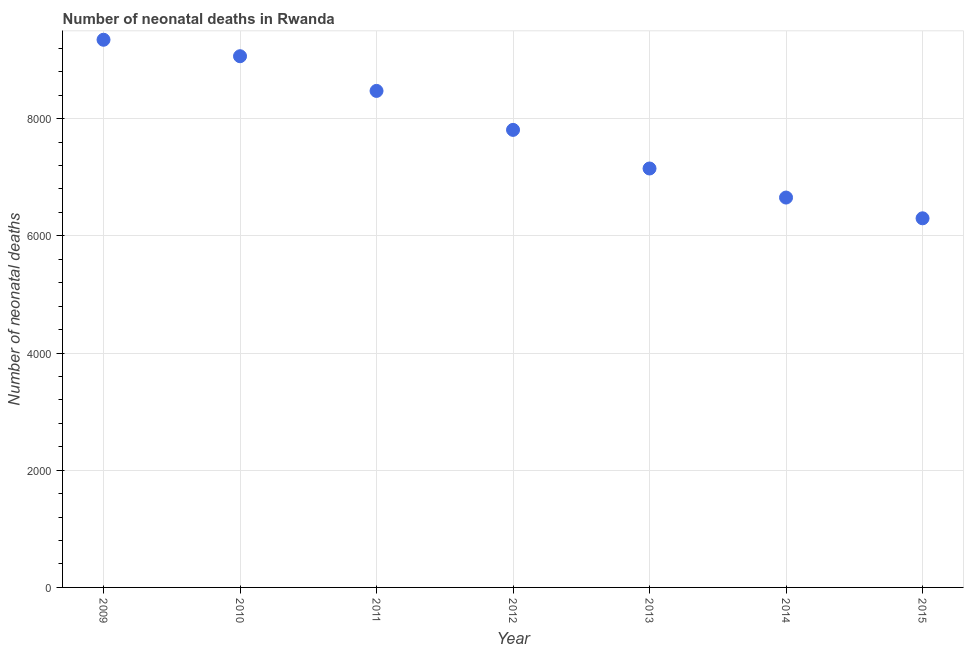What is the number of neonatal deaths in 2014?
Offer a terse response. 6653. Across all years, what is the maximum number of neonatal deaths?
Your response must be concise. 9346. Across all years, what is the minimum number of neonatal deaths?
Your response must be concise. 6299. In which year was the number of neonatal deaths minimum?
Give a very brief answer. 2015. What is the sum of the number of neonatal deaths?
Your answer should be very brief. 5.48e+04. What is the difference between the number of neonatal deaths in 2009 and 2010?
Provide a short and direct response. 281. What is the average number of neonatal deaths per year?
Your response must be concise. 7827.57. What is the median number of neonatal deaths?
Offer a very short reply. 7808. In how many years, is the number of neonatal deaths greater than 3200 ?
Make the answer very short. 7. What is the ratio of the number of neonatal deaths in 2009 to that in 2011?
Provide a succinct answer. 1.1. Is the number of neonatal deaths in 2011 less than that in 2014?
Ensure brevity in your answer.  No. Is the difference between the number of neonatal deaths in 2013 and 2015 greater than the difference between any two years?
Provide a succinct answer. No. What is the difference between the highest and the second highest number of neonatal deaths?
Your answer should be very brief. 281. Is the sum of the number of neonatal deaths in 2012 and 2015 greater than the maximum number of neonatal deaths across all years?
Offer a very short reply. Yes. What is the difference between the highest and the lowest number of neonatal deaths?
Your answer should be compact. 3047. How many dotlines are there?
Keep it short and to the point. 1. How many years are there in the graph?
Ensure brevity in your answer.  7. What is the difference between two consecutive major ticks on the Y-axis?
Make the answer very short. 2000. Are the values on the major ticks of Y-axis written in scientific E-notation?
Make the answer very short. No. Does the graph contain any zero values?
Your answer should be compact. No. What is the title of the graph?
Offer a terse response. Number of neonatal deaths in Rwanda. What is the label or title of the Y-axis?
Make the answer very short. Number of neonatal deaths. What is the Number of neonatal deaths in 2009?
Give a very brief answer. 9346. What is the Number of neonatal deaths in 2010?
Offer a very short reply. 9065. What is the Number of neonatal deaths in 2011?
Provide a succinct answer. 8473. What is the Number of neonatal deaths in 2012?
Provide a succinct answer. 7808. What is the Number of neonatal deaths in 2013?
Give a very brief answer. 7149. What is the Number of neonatal deaths in 2014?
Your response must be concise. 6653. What is the Number of neonatal deaths in 2015?
Your answer should be compact. 6299. What is the difference between the Number of neonatal deaths in 2009 and 2010?
Provide a succinct answer. 281. What is the difference between the Number of neonatal deaths in 2009 and 2011?
Ensure brevity in your answer.  873. What is the difference between the Number of neonatal deaths in 2009 and 2012?
Provide a succinct answer. 1538. What is the difference between the Number of neonatal deaths in 2009 and 2013?
Give a very brief answer. 2197. What is the difference between the Number of neonatal deaths in 2009 and 2014?
Your answer should be very brief. 2693. What is the difference between the Number of neonatal deaths in 2009 and 2015?
Make the answer very short. 3047. What is the difference between the Number of neonatal deaths in 2010 and 2011?
Your answer should be compact. 592. What is the difference between the Number of neonatal deaths in 2010 and 2012?
Offer a very short reply. 1257. What is the difference between the Number of neonatal deaths in 2010 and 2013?
Your answer should be compact. 1916. What is the difference between the Number of neonatal deaths in 2010 and 2014?
Ensure brevity in your answer.  2412. What is the difference between the Number of neonatal deaths in 2010 and 2015?
Make the answer very short. 2766. What is the difference between the Number of neonatal deaths in 2011 and 2012?
Keep it short and to the point. 665. What is the difference between the Number of neonatal deaths in 2011 and 2013?
Make the answer very short. 1324. What is the difference between the Number of neonatal deaths in 2011 and 2014?
Make the answer very short. 1820. What is the difference between the Number of neonatal deaths in 2011 and 2015?
Offer a very short reply. 2174. What is the difference between the Number of neonatal deaths in 2012 and 2013?
Your answer should be very brief. 659. What is the difference between the Number of neonatal deaths in 2012 and 2014?
Provide a succinct answer. 1155. What is the difference between the Number of neonatal deaths in 2012 and 2015?
Your response must be concise. 1509. What is the difference between the Number of neonatal deaths in 2013 and 2014?
Ensure brevity in your answer.  496. What is the difference between the Number of neonatal deaths in 2013 and 2015?
Your response must be concise. 850. What is the difference between the Number of neonatal deaths in 2014 and 2015?
Your response must be concise. 354. What is the ratio of the Number of neonatal deaths in 2009 to that in 2010?
Make the answer very short. 1.03. What is the ratio of the Number of neonatal deaths in 2009 to that in 2011?
Offer a terse response. 1.1. What is the ratio of the Number of neonatal deaths in 2009 to that in 2012?
Your answer should be compact. 1.2. What is the ratio of the Number of neonatal deaths in 2009 to that in 2013?
Offer a terse response. 1.31. What is the ratio of the Number of neonatal deaths in 2009 to that in 2014?
Your response must be concise. 1.41. What is the ratio of the Number of neonatal deaths in 2009 to that in 2015?
Your response must be concise. 1.48. What is the ratio of the Number of neonatal deaths in 2010 to that in 2011?
Keep it short and to the point. 1.07. What is the ratio of the Number of neonatal deaths in 2010 to that in 2012?
Your answer should be very brief. 1.16. What is the ratio of the Number of neonatal deaths in 2010 to that in 2013?
Your answer should be very brief. 1.27. What is the ratio of the Number of neonatal deaths in 2010 to that in 2014?
Your answer should be very brief. 1.36. What is the ratio of the Number of neonatal deaths in 2010 to that in 2015?
Provide a succinct answer. 1.44. What is the ratio of the Number of neonatal deaths in 2011 to that in 2012?
Provide a succinct answer. 1.08. What is the ratio of the Number of neonatal deaths in 2011 to that in 2013?
Provide a succinct answer. 1.19. What is the ratio of the Number of neonatal deaths in 2011 to that in 2014?
Provide a short and direct response. 1.27. What is the ratio of the Number of neonatal deaths in 2011 to that in 2015?
Your answer should be compact. 1.34. What is the ratio of the Number of neonatal deaths in 2012 to that in 2013?
Offer a terse response. 1.09. What is the ratio of the Number of neonatal deaths in 2012 to that in 2014?
Provide a succinct answer. 1.17. What is the ratio of the Number of neonatal deaths in 2012 to that in 2015?
Your answer should be very brief. 1.24. What is the ratio of the Number of neonatal deaths in 2013 to that in 2014?
Provide a short and direct response. 1.07. What is the ratio of the Number of neonatal deaths in 2013 to that in 2015?
Your answer should be compact. 1.14. What is the ratio of the Number of neonatal deaths in 2014 to that in 2015?
Your answer should be very brief. 1.06. 